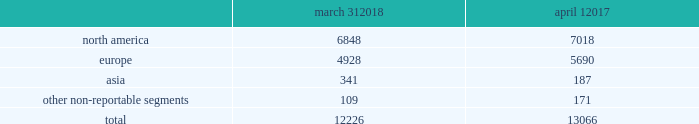Concession-based shop-within-shops .
In addition , we sell our products online through various third-party digital partner commerce sites .
In asia , our wholesale business is comprised primarily of sales to department stores , with related products distributed through shop-within-shops .
No operating segments were aggregated to form our reportable segments .
In addition to these reportable segments , we also have other non-reportable segments , representing approximately 7% ( 7 % ) of our fiscal 2018 net revenues , which primarily consist of ( i ) sales of club monaco branded products made through our retail businesses in the u.s. , canada , and europe , and our licensing alliances in europe and asia , ( ii ) sales of ralph lauren branded products made through our wholesale business in latin america , and ( iii ) royalty revenues earned through our global licensing alliances , excluding club monaco .
This segment structure is consistent with how we establish our overall business strategy , allocate resources , and assess performance of our company .
Approximately 45% ( 45 % ) of our fiscal 2018 net revenues were earned outside of the u.s .
See note 19 to the accompanying consolidated financial statements for a summary of net revenues and operating income by segment , as well as net revenues and long-lived assets by geographic location .
Our wholesale business our wholesale business sells our products globally to leading upscale and certain mid-tier department stores , specialty stores , and golf and pro shops .
We have continued to focus on elevating our brand by improving in-store product assortment and presentation , as well as full-price sell-throughs to consumers .
As of the end of fiscal 2018 , our wholesale products were sold through over 12000 doors worldwide , with the majority in specialty stores .
Our products are also increasingly being sold through the digital commerce sites of many of our wholesale customers .
The primary product offerings sold through our wholesale channels of distribution include apparel , accessories , and home furnishings .
Our luxury brands , including ralph lauren collection and ralph lauren purple label , are distributed worldwide through a limited number of premier fashion retailers .
In north america , our wholesale business is comprised primarily of sales to department stores , and to a lesser extent , specialty stores .
In europe , our wholesale business is comprised of a varying mix of sales to both department stores and specialty stores , depending on the country .
In asia , our wholesale business is comprised primarily of sales to department stores , with related products distributed through shop-within-shops .
We also distribute our wholesale products to certain licensed stores operated by our partners in latin america , asia , europe , and the middle east .
We sell the majority of our excess and out-of-season products through secondary distribution channels worldwide , including our retail factory stores .
Worldwide wholesale distribution channels the table presents by segment the number of wholesale doors in our primary channels of distribution as of march 31 , 2018 and april 1 , march 31 , april 1 .
We have three key wholesale customers that generate significant sales volume .
During fiscal 2018 , sales to our largest wholesale customer , macy's , inc .
( "macy's" ) , accounted for approximately 8% ( 8 % ) of our total net revenues .
Further , during fiscal 2018 , sales to our three largest wholesale customers , including macy's , accounted for approximately 19% ( 19 % ) of our total net revenues , as compared to approximately 21% ( 21 % ) during fiscal 2017 .
Substantially all sales to our three largest wholesale customers related to our north america segment .
Our products are sold primarily by our own sales forces .
Our wholesale business maintains its primary showrooms in new york city .
In addition , we maintain regional showrooms in bologna , geneva , london , madrid , munich , panama , paris , and stockholm. .
What percentage of wholesale distribution channels are due to asia as of march 31 , 2018? 
Computations: (341 / 12226)
Answer: 0.02789. 